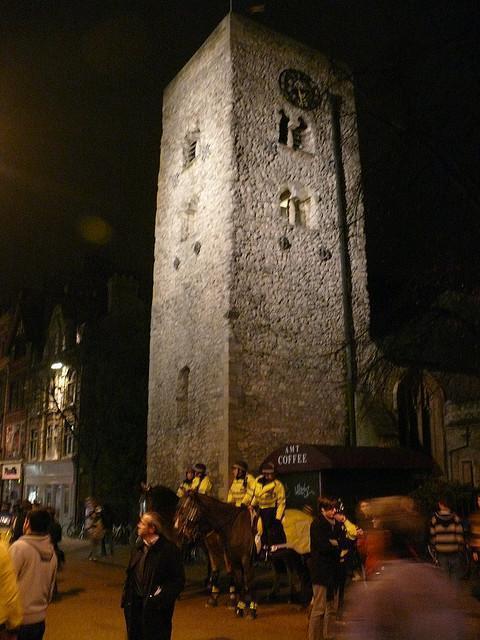What material composes this old square tower?
Indicate the correct response by choosing from the four available options to answer the question.
Options: Brick, wood, cobblestone, mud. Cobblestone. What material is the construction of this tower?
Indicate the correct response and explain using: 'Answer: answer
Rationale: rationale.'
Options: Cobblestone, wood, brick, metal. Answer: cobblestone.
Rationale: The tower is grey. it is not made out of brick, wood, or metal. 